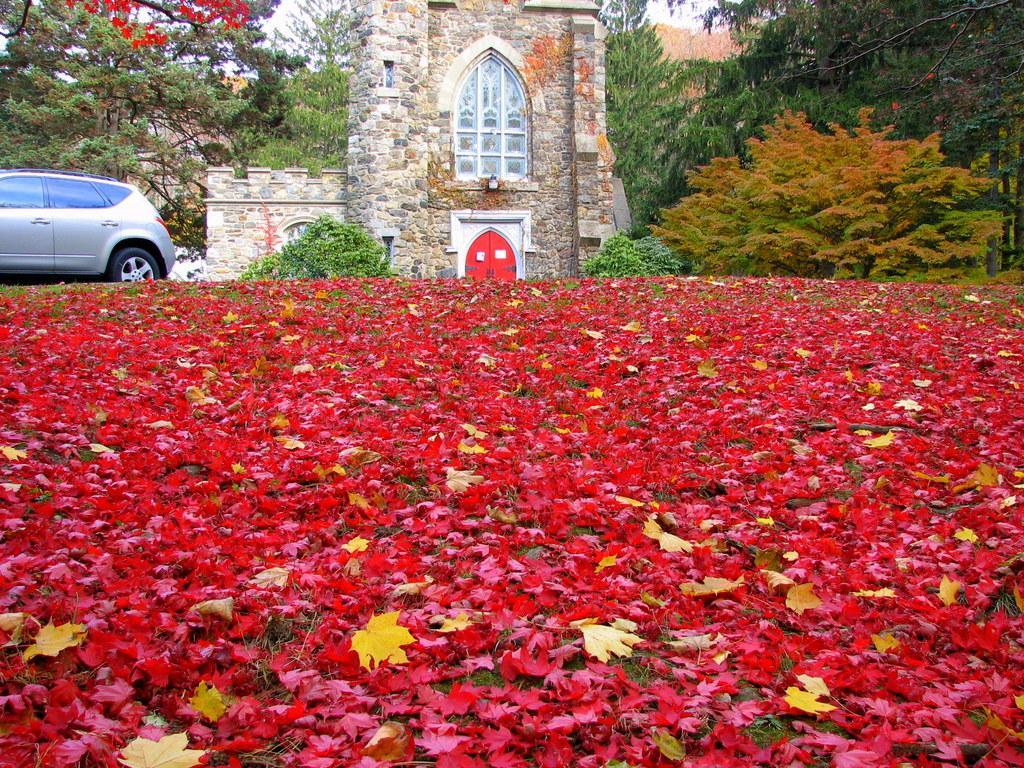In one or two sentences, can you explain what this image depicts? In this image we can see many leaves on the ground, and on the left we can see a vehicle, in the middle we can see a house, at the back we can see many trees. 